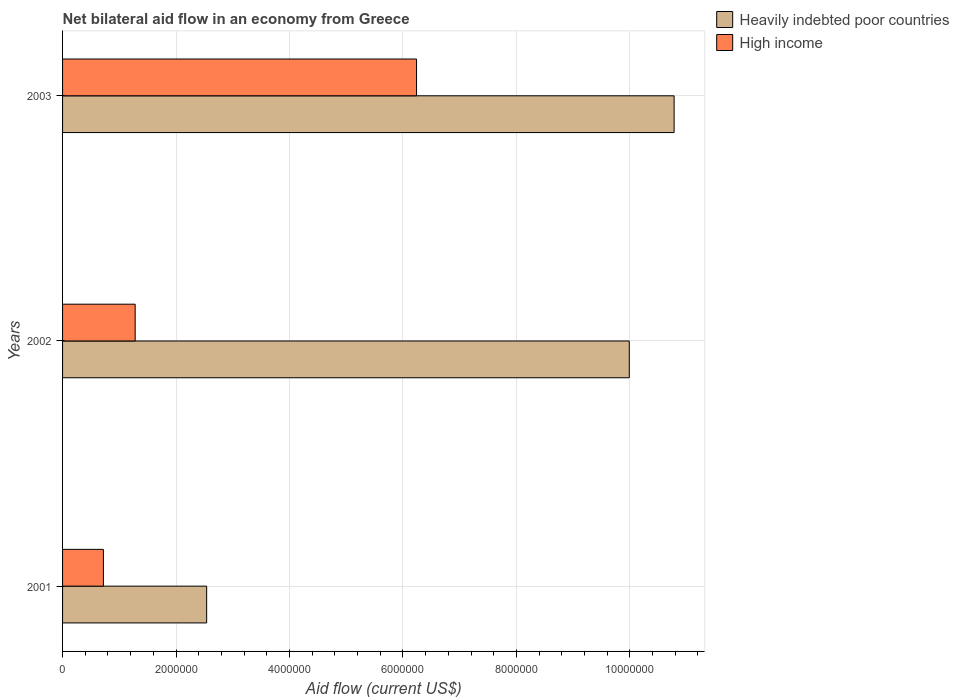How many groups of bars are there?
Provide a succinct answer. 3. How many bars are there on the 3rd tick from the bottom?
Keep it short and to the point. 2. What is the label of the 1st group of bars from the top?
Offer a very short reply. 2003. In how many cases, is the number of bars for a given year not equal to the number of legend labels?
Provide a short and direct response. 0. What is the net bilateral aid flow in Heavily indebted poor countries in 2002?
Provide a short and direct response. 9.99e+06. Across all years, what is the maximum net bilateral aid flow in High income?
Your answer should be compact. 6.24e+06. Across all years, what is the minimum net bilateral aid flow in Heavily indebted poor countries?
Your answer should be compact. 2.54e+06. In which year was the net bilateral aid flow in Heavily indebted poor countries minimum?
Offer a terse response. 2001. What is the total net bilateral aid flow in Heavily indebted poor countries in the graph?
Keep it short and to the point. 2.33e+07. What is the difference between the net bilateral aid flow in Heavily indebted poor countries in 2002 and that in 2003?
Ensure brevity in your answer.  -7.90e+05. What is the difference between the net bilateral aid flow in Heavily indebted poor countries in 2001 and the net bilateral aid flow in High income in 2002?
Offer a very short reply. 1.26e+06. What is the average net bilateral aid flow in High income per year?
Your answer should be compact. 2.75e+06. In the year 2003, what is the difference between the net bilateral aid flow in High income and net bilateral aid flow in Heavily indebted poor countries?
Offer a terse response. -4.54e+06. What is the ratio of the net bilateral aid flow in High income in 2002 to that in 2003?
Offer a terse response. 0.21. Is the net bilateral aid flow in Heavily indebted poor countries in 2001 less than that in 2003?
Your answer should be very brief. Yes. Is the difference between the net bilateral aid flow in High income in 2001 and 2003 greater than the difference between the net bilateral aid flow in Heavily indebted poor countries in 2001 and 2003?
Keep it short and to the point. Yes. What is the difference between the highest and the second highest net bilateral aid flow in High income?
Your response must be concise. 4.96e+06. What is the difference between the highest and the lowest net bilateral aid flow in High income?
Make the answer very short. 5.52e+06. What does the 2nd bar from the top in 2002 represents?
Your response must be concise. Heavily indebted poor countries. What does the 1st bar from the bottom in 2003 represents?
Your response must be concise. Heavily indebted poor countries. How many bars are there?
Your response must be concise. 6. Are the values on the major ticks of X-axis written in scientific E-notation?
Your answer should be very brief. No. Does the graph contain any zero values?
Offer a very short reply. No. How many legend labels are there?
Provide a short and direct response. 2. What is the title of the graph?
Make the answer very short. Net bilateral aid flow in an economy from Greece. What is the label or title of the X-axis?
Your answer should be very brief. Aid flow (current US$). What is the label or title of the Y-axis?
Offer a terse response. Years. What is the Aid flow (current US$) in Heavily indebted poor countries in 2001?
Provide a short and direct response. 2.54e+06. What is the Aid flow (current US$) of High income in 2001?
Keep it short and to the point. 7.20e+05. What is the Aid flow (current US$) of Heavily indebted poor countries in 2002?
Your answer should be very brief. 9.99e+06. What is the Aid flow (current US$) in High income in 2002?
Your response must be concise. 1.28e+06. What is the Aid flow (current US$) in Heavily indebted poor countries in 2003?
Give a very brief answer. 1.08e+07. What is the Aid flow (current US$) in High income in 2003?
Your response must be concise. 6.24e+06. Across all years, what is the maximum Aid flow (current US$) of Heavily indebted poor countries?
Your answer should be compact. 1.08e+07. Across all years, what is the maximum Aid flow (current US$) of High income?
Ensure brevity in your answer.  6.24e+06. Across all years, what is the minimum Aid flow (current US$) of Heavily indebted poor countries?
Ensure brevity in your answer.  2.54e+06. Across all years, what is the minimum Aid flow (current US$) of High income?
Keep it short and to the point. 7.20e+05. What is the total Aid flow (current US$) in Heavily indebted poor countries in the graph?
Your answer should be compact. 2.33e+07. What is the total Aid flow (current US$) in High income in the graph?
Your answer should be very brief. 8.24e+06. What is the difference between the Aid flow (current US$) in Heavily indebted poor countries in 2001 and that in 2002?
Your response must be concise. -7.45e+06. What is the difference between the Aid flow (current US$) of High income in 2001 and that in 2002?
Offer a very short reply. -5.60e+05. What is the difference between the Aid flow (current US$) in Heavily indebted poor countries in 2001 and that in 2003?
Your response must be concise. -8.24e+06. What is the difference between the Aid flow (current US$) of High income in 2001 and that in 2003?
Your answer should be very brief. -5.52e+06. What is the difference between the Aid flow (current US$) of Heavily indebted poor countries in 2002 and that in 2003?
Keep it short and to the point. -7.90e+05. What is the difference between the Aid flow (current US$) in High income in 2002 and that in 2003?
Provide a short and direct response. -4.96e+06. What is the difference between the Aid flow (current US$) of Heavily indebted poor countries in 2001 and the Aid flow (current US$) of High income in 2002?
Your answer should be very brief. 1.26e+06. What is the difference between the Aid flow (current US$) in Heavily indebted poor countries in 2001 and the Aid flow (current US$) in High income in 2003?
Offer a very short reply. -3.70e+06. What is the difference between the Aid flow (current US$) of Heavily indebted poor countries in 2002 and the Aid flow (current US$) of High income in 2003?
Your answer should be very brief. 3.75e+06. What is the average Aid flow (current US$) in Heavily indebted poor countries per year?
Provide a short and direct response. 7.77e+06. What is the average Aid flow (current US$) of High income per year?
Keep it short and to the point. 2.75e+06. In the year 2001, what is the difference between the Aid flow (current US$) of Heavily indebted poor countries and Aid flow (current US$) of High income?
Provide a succinct answer. 1.82e+06. In the year 2002, what is the difference between the Aid flow (current US$) of Heavily indebted poor countries and Aid flow (current US$) of High income?
Provide a short and direct response. 8.71e+06. In the year 2003, what is the difference between the Aid flow (current US$) of Heavily indebted poor countries and Aid flow (current US$) of High income?
Give a very brief answer. 4.54e+06. What is the ratio of the Aid flow (current US$) of Heavily indebted poor countries in 2001 to that in 2002?
Provide a short and direct response. 0.25. What is the ratio of the Aid flow (current US$) in High income in 2001 to that in 2002?
Keep it short and to the point. 0.56. What is the ratio of the Aid flow (current US$) of Heavily indebted poor countries in 2001 to that in 2003?
Your response must be concise. 0.24. What is the ratio of the Aid flow (current US$) in High income in 2001 to that in 2003?
Your answer should be very brief. 0.12. What is the ratio of the Aid flow (current US$) of Heavily indebted poor countries in 2002 to that in 2003?
Make the answer very short. 0.93. What is the ratio of the Aid flow (current US$) in High income in 2002 to that in 2003?
Keep it short and to the point. 0.21. What is the difference between the highest and the second highest Aid flow (current US$) of Heavily indebted poor countries?
Ensure brevity in your answer.  7.90e+05. What is the difference between the highest and the second highest Aid flow (current US$) of High income?
Give a very brief answer. 4.96e+06. What is the difference between the highest and the lowest Aid flow (current US$) of Heavily indebted poor countries?
Offer a terse response. 8.24e+06. What is the difference between the highest and the lowest Aid flow (current US$) of High income?
Your answer should be very brief. 5.52e+06. 